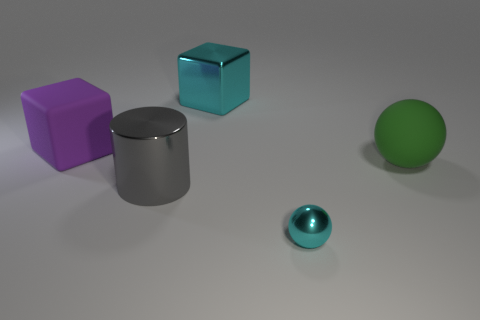Add 2 green things. How many objects exist? 7 Subtract 1 cylinders. How many cylinders are left? 0 Subtract all green cubes. Subtract all blue cylinders. How many cubes are left? 2 Subtract all brown cylinders. How many green spheres are left? 1 Subtract all large yellow balls. Subtract all big matte things. How many objects are left? 3 Add 1 big cyan cubes. How many big cyan cubes are left? 2 Add 3 small cubes. How many small cubes exist? 3 Subtract 1 cyan spheres. How many objects are left? 4 Subtract all spheres. How many objects are left? 3 